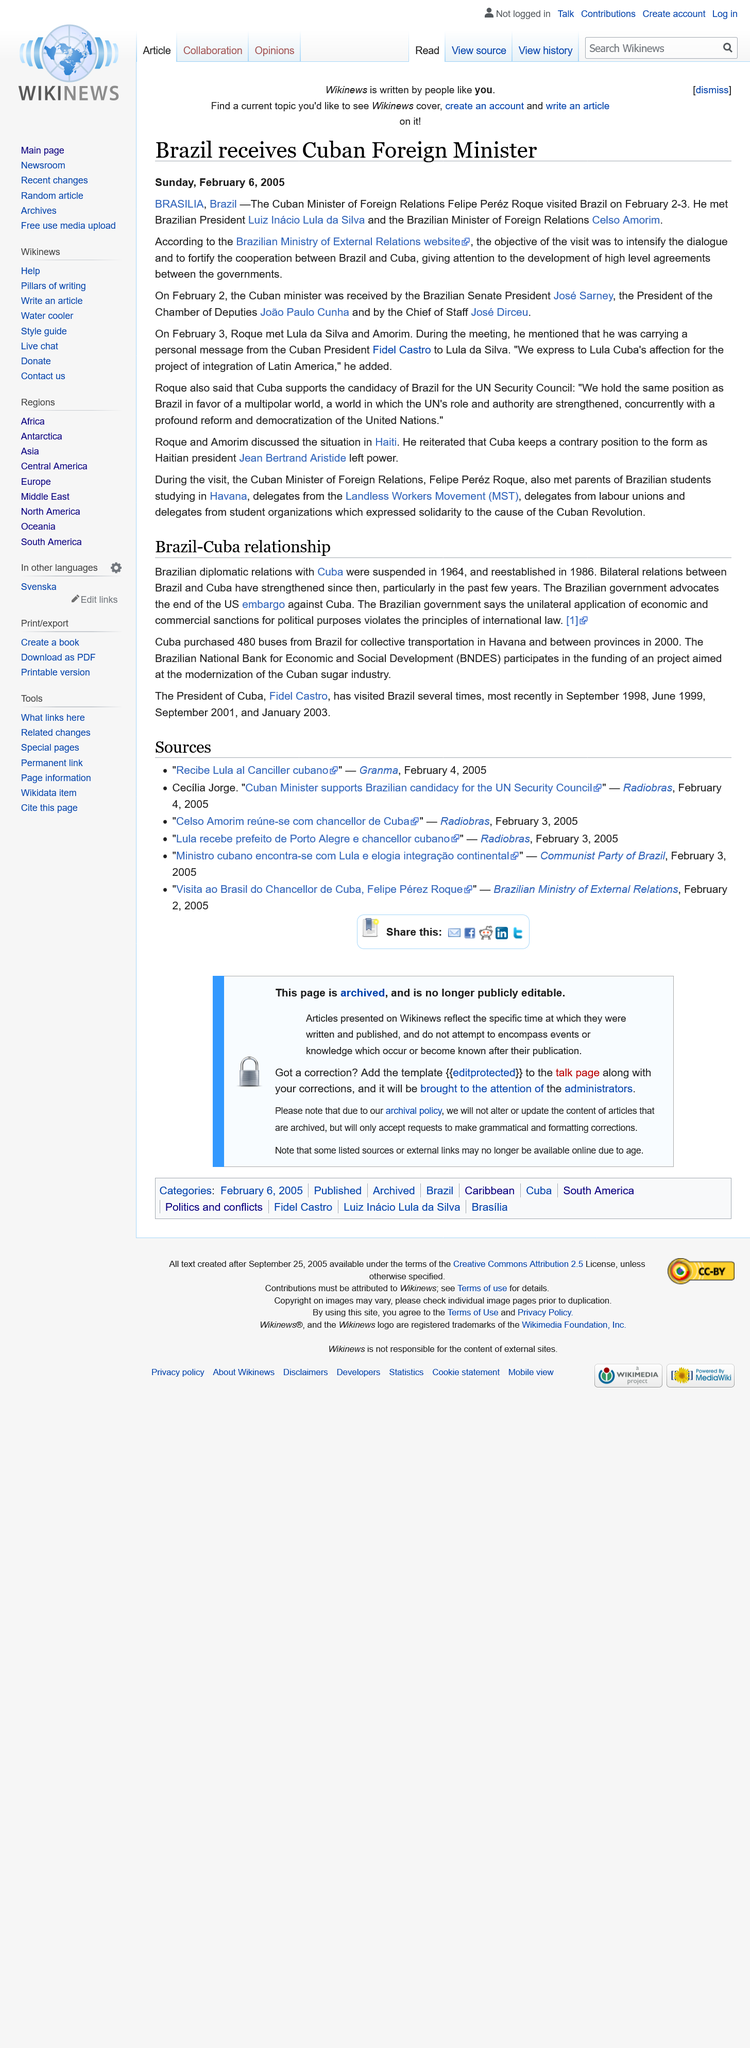Give some essential details in this illustration. In 1964, Brazilian diplomatic relations with Cuba were suspended. Felipe Perez Roque is the current Cuban foreign relations minister. The Cuban foreign minister visited on 2nd and 3rd February. In 2000, Cuba purchased 480 buses from Brazil. In the year 1986, diplomatic relations between Brazil and Cuba were reestablished. 